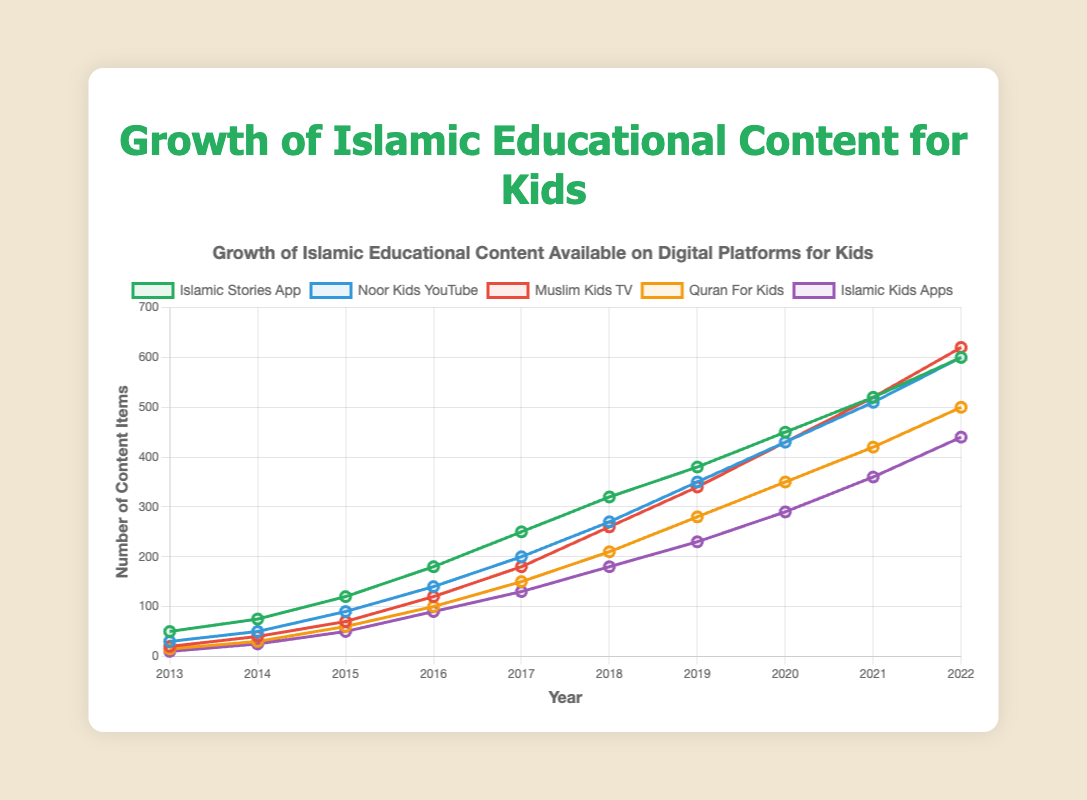What is the total number of Islamic educational content items available across all platforms in 2022? Sum the data points for 2022 across all platforms: Islamic Stories App (600) + Noor Kids YouTube (600) + Muslim Kids TV (620) + Quran For Kids (500) + Islamic Kids Apps (440) = 2760.
Answer: 2760 Which platform had the highest growth in Islamic educational content from 2013 to 2022? By comparing the difference between the 2022 and 2013 data points for all platforms: Islamic Stories App (600-50 = 550), Noor Kids YouTube (600-30 = 570), Muslim Kids TV (620-20 = 600), Quran For Kids (500-15 = 485), Islamic Kids Apps (440-10 = 430). Muslim Kids TV had the highest growth.
Answer: Muslim Kids TV Between Islamic Stories App and Noor Kids YouTube, which had more content in 2018? Comparing the 2018 data points for Islamic Stories App (320) and Noor Kids YouTube (270), Islamic Stories App had more content.
Answer: Islamic Stories App Which platform saw a steady increase each year from 2013 to 2022? By observing the lines, all platforms — Islamic Stories App, Noor Kids YouTube, Muslim Kids TV, Quran For Kids, and Islamic Kids Apps — showed a steady increase every year.
Answer: All platforms What is the average number of content items for Muslim Kids TV between 2017 and 2020? Sum the data points for Muslim Kids TV between 2017 and 2020: 180 (2017) + 260 (2018) + 340 (2019) + 430 (2020) = 1210. Divide by 4 years: 1210 / 4 = 302.5
Answer: 302.5 Which platform had the smallest amount of content in 2015? Comparing the 2015 data points for all platforms: Islamic Stories App (120), Noor Kids YouTube (90), Muslim Kids TV (70), Quran For Kids (60), Islamic Kids Apps (50). Islamic Kids Apps had the smallest amount.
Answer: Islamic Kids Apps In which year did Quran For Kids reach 100 content items? Locate the year where the data point for Quran For Kids is 100, which is in 2016.
Answer: 2016 Which platform had the least growth from 2013 to 2014? Compare the growth for each platform from 2013 to 2014: Islamic Stories App (75-50 = 25), Noor Kids YouTube (50-30 = 20), Muslim Kids TV (40-20 = 20), Quran For Kids (30-15 = 15), Islamic Kids Apps (25-10 = 15). Quran For Kids and Islamic Kids Apps had the least growth (15).
Answer: Quran For Kids and Islamic Kids Apps What is the difference in the number of content items between Noor Kids YouTube and Islamic Kids Apps in 2021? Calculate the difference between 2021 data points: Noor Kids YouTube (510) - Islamic Kids Apps (360) = 150.
Answer: 150 Which platform had more content items in 2020, Muslim Kids TV or Quran For Kids? Comparing the 2020 data points for Muslim Kids TV (430) and Quran For Kids (350), Muslim Kids TV had more content items.
Answer: Muslim Kids TV 